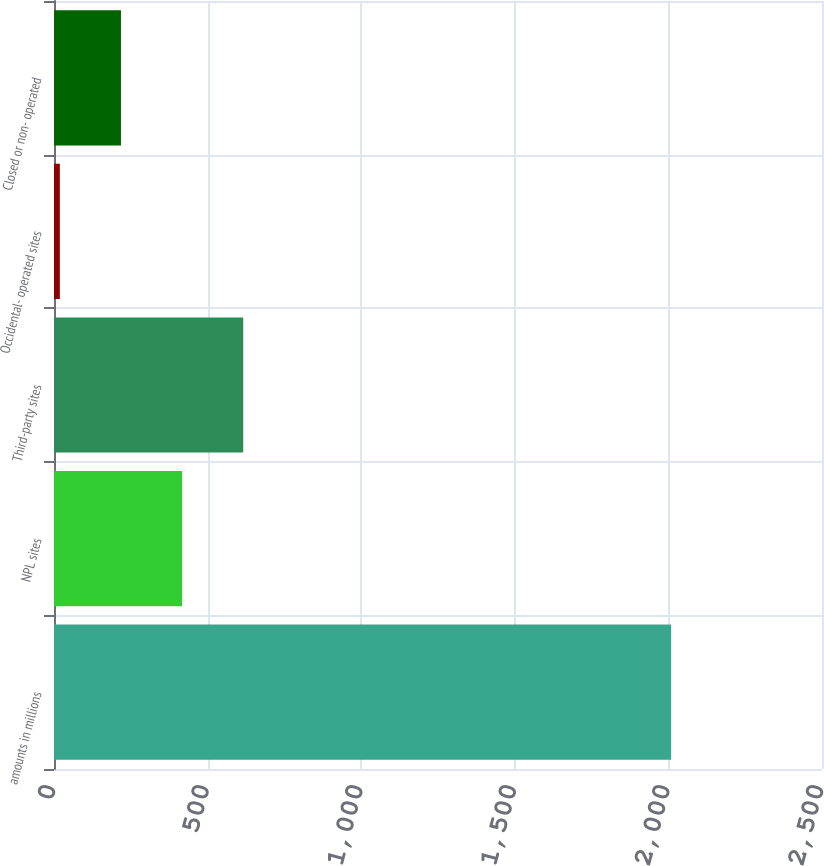<chart> <loc_0><loc_0><loc_500><loc_500><bar_chart><fcel>amounts in millions<fcel>NPL sites<fcel>Third-party sites<fcel>Occidental- operated sites<fcel>Closed or non- operated<nl><fcel>2009<fcel>417<fcel>616<fcel>19<fcel>218<nl></chart> 